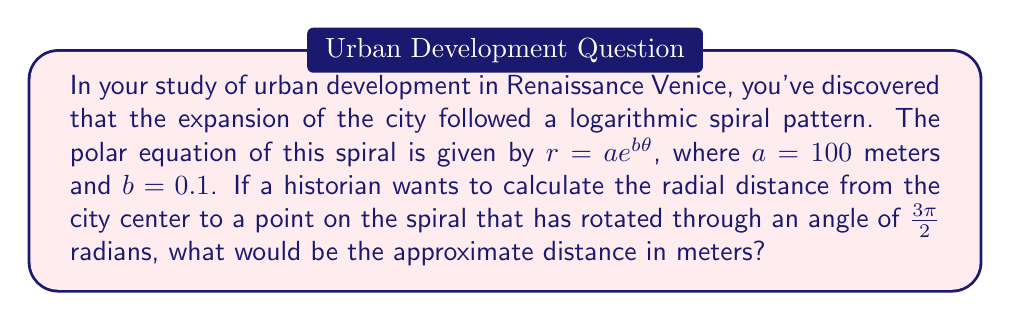Can you answer this question? To solve this problem, we need to use the given polar equation of the logarithmic spiral and substitute the known values. Let's break it down step-by-step:

1) The polar equation of the logarithmic spiral is:
   $r = ae^{b\theta}$

2) We are given that:
   $a = 100$ meters
   $b = 0.1$
   $\theta = \frac{3\pi}{2}$ radians

3) Let's substitute these values into the equation:
   $r = 100e^{0.1 \cdot \frac{3\pi}{2}}$

4) Now, let's calculate:
   $r = 100e^{0.1 \cdot \frac{3\pi}{2}}$
   $r = 100e^{0.1 \cdot 4.71239}$ (approximating $\frac{3\pi}{2}$ to 5 decimal places)
   $r = 100e^{0.471239}$

5) Using a calculator or computer, we can evaluate this expression:
   $r \approx 160.18$ meters

Therefore, the radial distance from the city center to the point on the spiral that has rotated through an angle of $\frac{3\pi}{2}$ radians is approximately 160.18 meters.

This result could be interpreted in the context of Venetian urban development as the distance from the historical center (perhaps St. Mark's Square) to a particular landmark or neighborhood that developed later in the Renaissance period.
Answer: $160.18$ meters (rounded to 2 decimal places) 